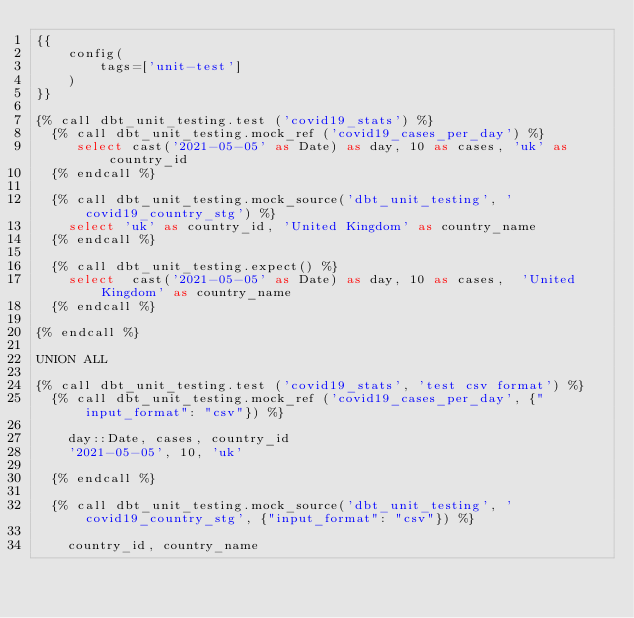Convert code to text. <code><loc_0><loc_0><loc_500><loc_500><_SQL_>{{
    config(
        tags=['unit-test']
    )
}}

{% call dbt_unit_testing.test ('covid19_stats') %}
  {% call dbt_unit_testing.mock_ref ('covid19_cases_per_day') %}
     select cast('2021-05-05' as Date) as day, 10 as cases, 'uk' as country_id
  {% endcall %}
 
  {% call dbt_unit_testing.mock_source('dbt_unit_testing', 'covid19_country_stg') %}
    select 'uk' as country_id, 'United Kingdom' as country_name
  {% endcall %}

  {% call dbt_unit_testing.expect() %}
    select  cast('2021-05-05' as Date) as day, 10 as cases,  'United Kingdom' as country_name			
  {% endcall %}

{% endcall %}

UNION ALL

{% call dbt_unit_testing.test ('covid19_stats', 'test csv format') %}
  {% call dbt_unit_testing.mock_ref ('covid19_cases_per_day', {"input_format": "csv"}) %}

    day::Date, cases, country_id
    '2021-05-05', 10, 'uk' 

  {% endcall %}
 
  {% call dbt_unit_testing.mock_source('dbt_unit_testing', 'covid19_country_stg', {"input_format": "csv"}) %}

    country_id, country_name</code> 